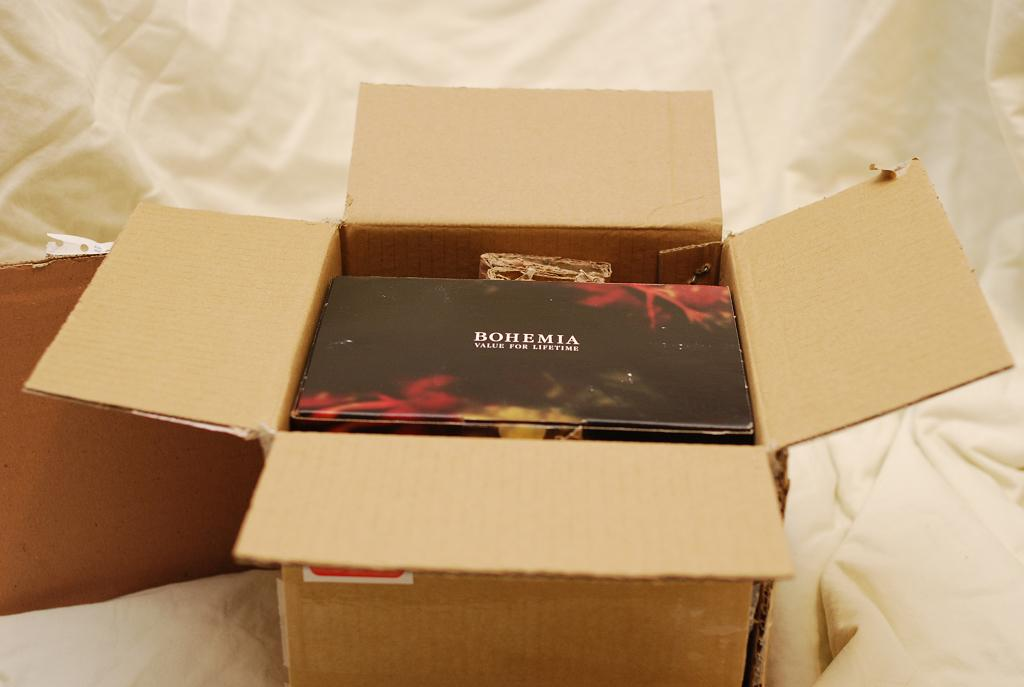Provide a one-sentence caption for the provided image. A black box saying BOHEMIA VALUE FOR A LIFETIME sits inside an open cardboard shipping box. 